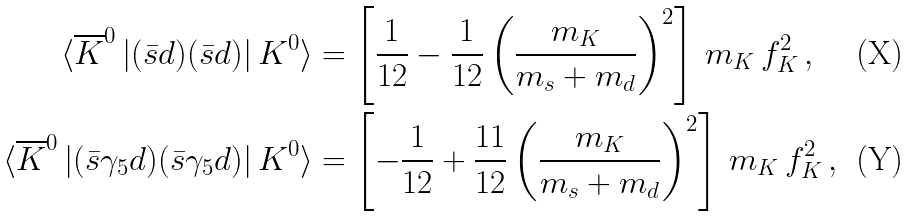Convert formula to latex. <formula><loc_0><loc_0><loc_500><loc_500>\langle \overline { K } ^ { 0 } \left | ( \bar { s } d ) ( \bar { s } d ) \right | K ^ { 0 } \rangle & = \left [ \frac { 1 } { 1 2 } - \frac { 1 } { 1 2 } \left ( \frac { m _ { K } } { m _ { s } + m _ { d } } \right ) ^ { 2 } \right ] \, m _ { K } \, f _ { K } ^ { 2 } \, , \\ \langle \overline { K } ^ { 0 } \left | ( \bar { s } \gamma _ { 5 } d ) ( \bar { s } \gamma _ { 5 } d ) \right | K ^ { 0 } \rangle & = \left [ - \frac { 1 } { 1 2 } + \frac { 1 1 } { 1 2 } \left ( \frac { m _ { K } } { m _ { s } + m _ { d } } \right ) ^ { 2 } \right ] \, m _ { K } \, f _ { K } ^ { 2 } \, ,</formula> 